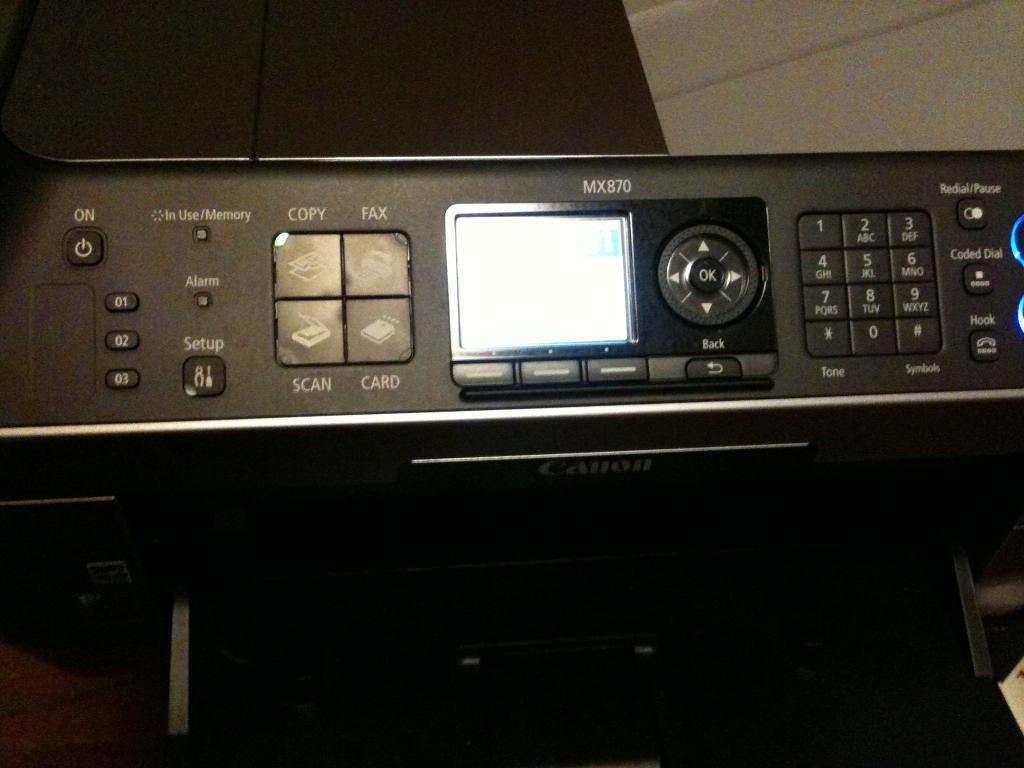In one or two sentences, can you explain what this image depicts? In this image I can see the electronic device and I can see few buttons. The image is dark. 